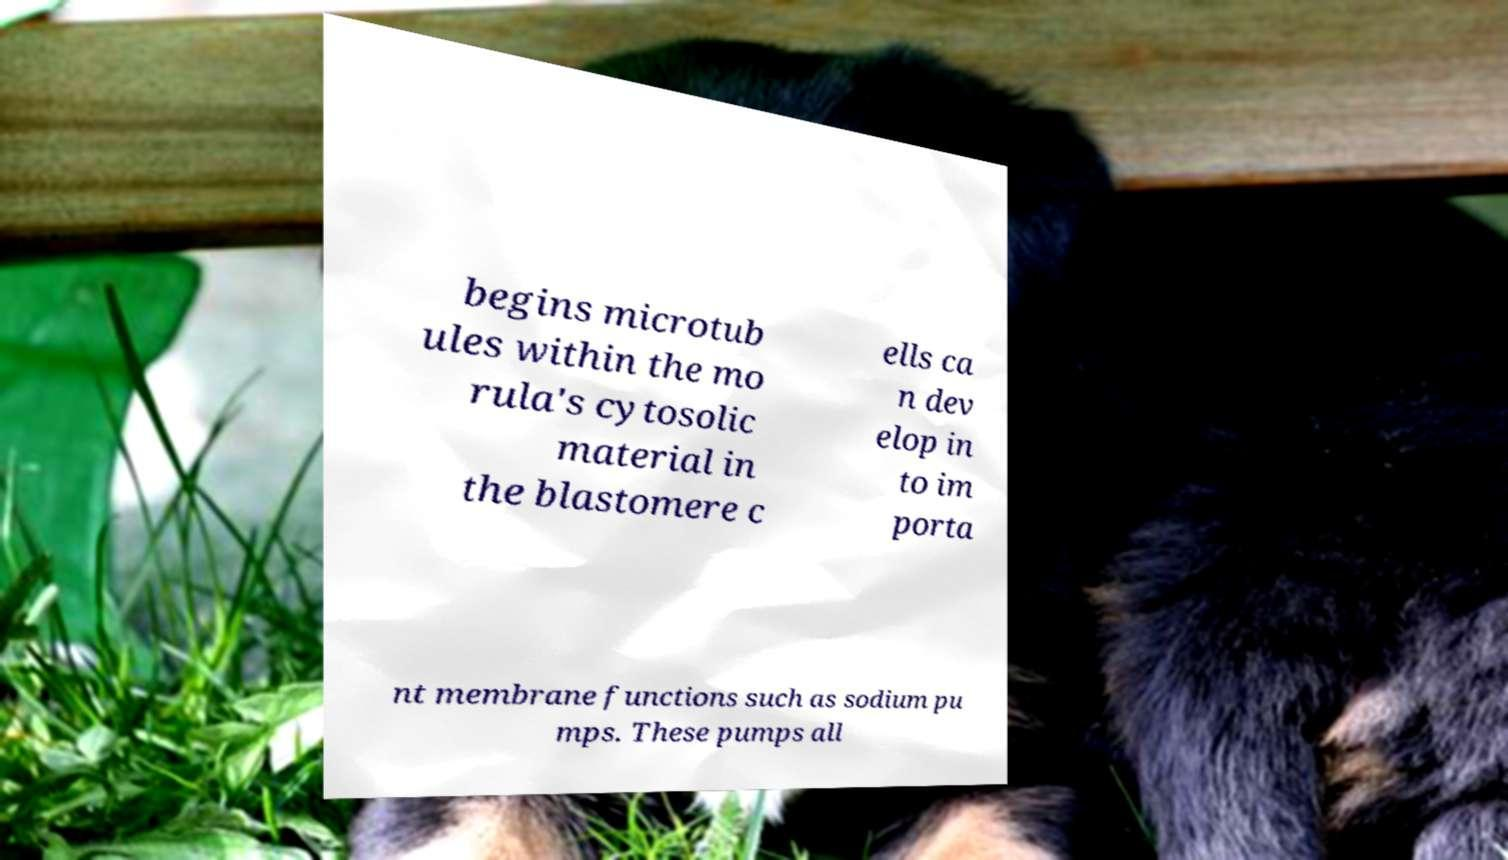For documentation purposes, I need the text within this image transcribed. Could you provide that? begins microtub ules within the mo rula's cytosolic material in the blastomere c ells ca n dev elop in to im porta nt membrane functions such as sodium pu mps. These pumps all 